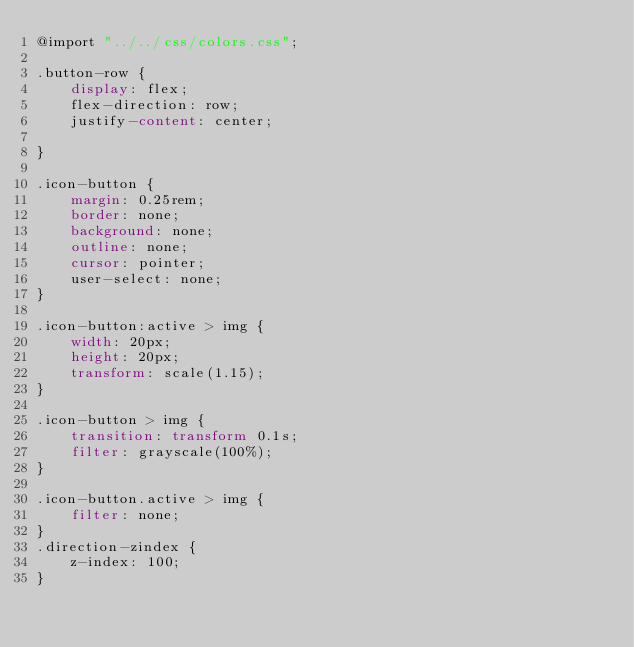Convert code to text. <code><loc_0><loc_0><loc_500><loc_500><_CSS_>@import "../../css/colors.css";

.button-row {
    display: flex;
    flex-direction: row;
    justify-content: center;

}

.icon-button {
    margin: 0.25rem;
    border: none;
    background: none;
    outline: none;
    cursor: pointer;
    user-select: none;
}

.icon-button:active > img {
    width: 20px;
    height: 20px;
    transform: scale(1.15);
}

.icon-button > img {
    transition: transform 0.1s;
    filter: grayscale(100%);
}

.icon-button.active > img {
    filter: none;
}
.direction-zindex {
    z-index: 100;
}</code> 